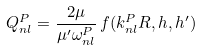<formula> <loc_0><loc_0><loc_500><loc_500>Q ^ { P } _ { n l } = \frac { 2 \mu } { \mu ^ { \prime } \omega _ { n l } ^ { P } } \, f ( k ^ { P } _ { n l } R , h , h ^ { \prime } )</formula> 